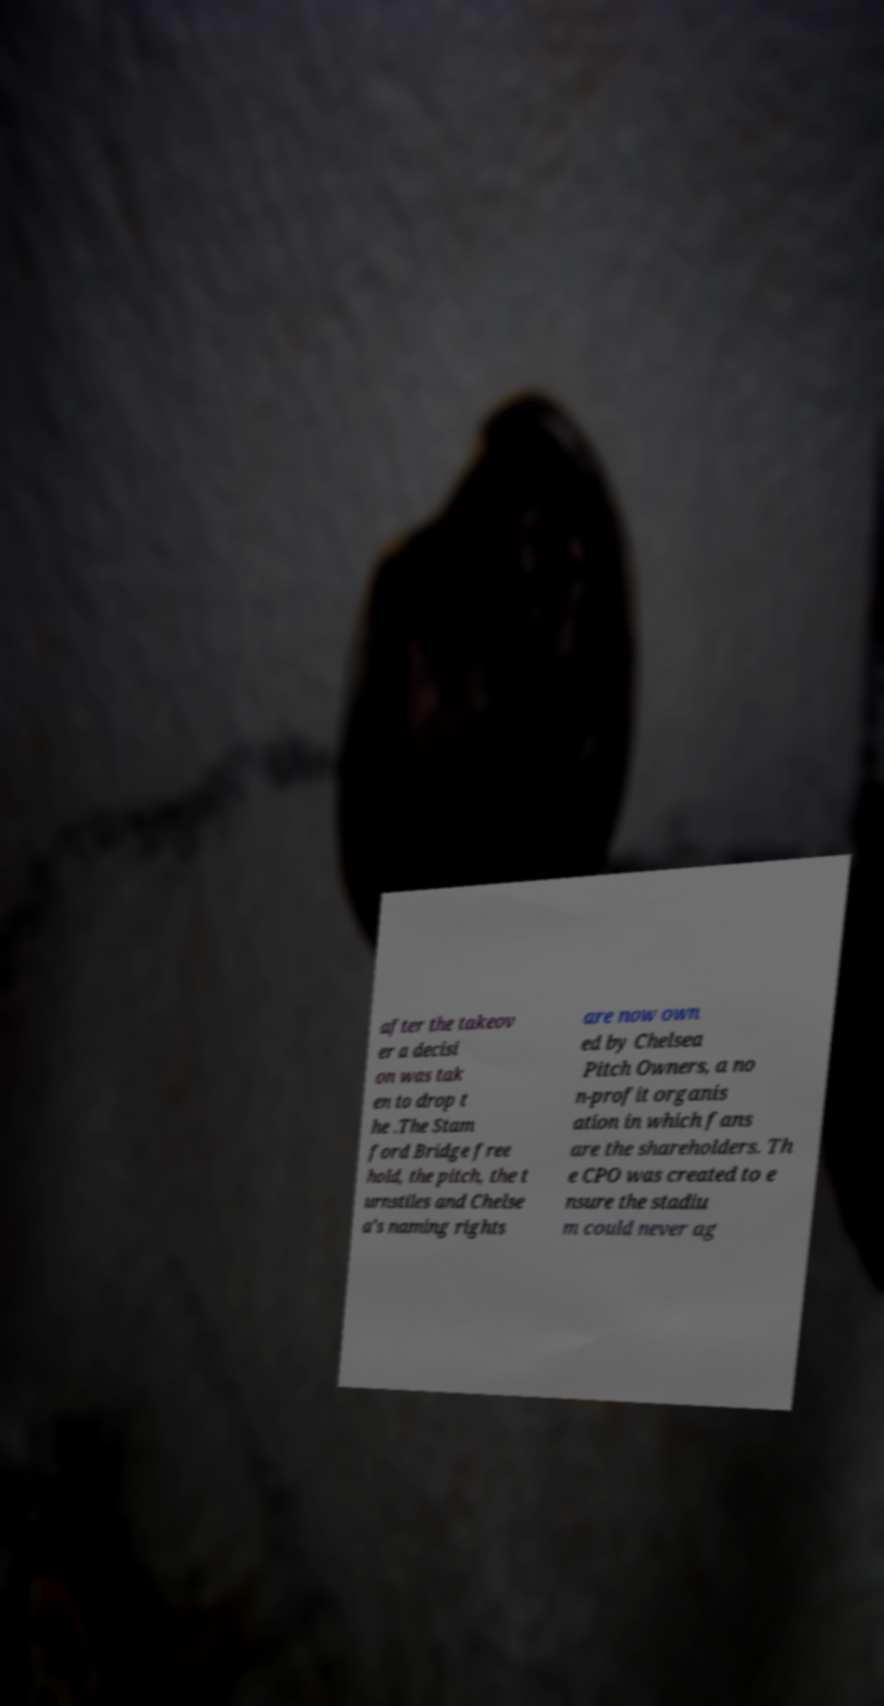Please identify and transcribe the text found in this image. after the takeov er a decisi on was tak en to drop t he .The Stam ford Bridge free hold, the pitch, the t urnstiles and Chelse a's naming rights are now own ed by Chelsea Pitch Owners, a no n-profit organis ation in which fans are the shareholders. Th e CPO was created to e nsure the stadiu m could never ag 